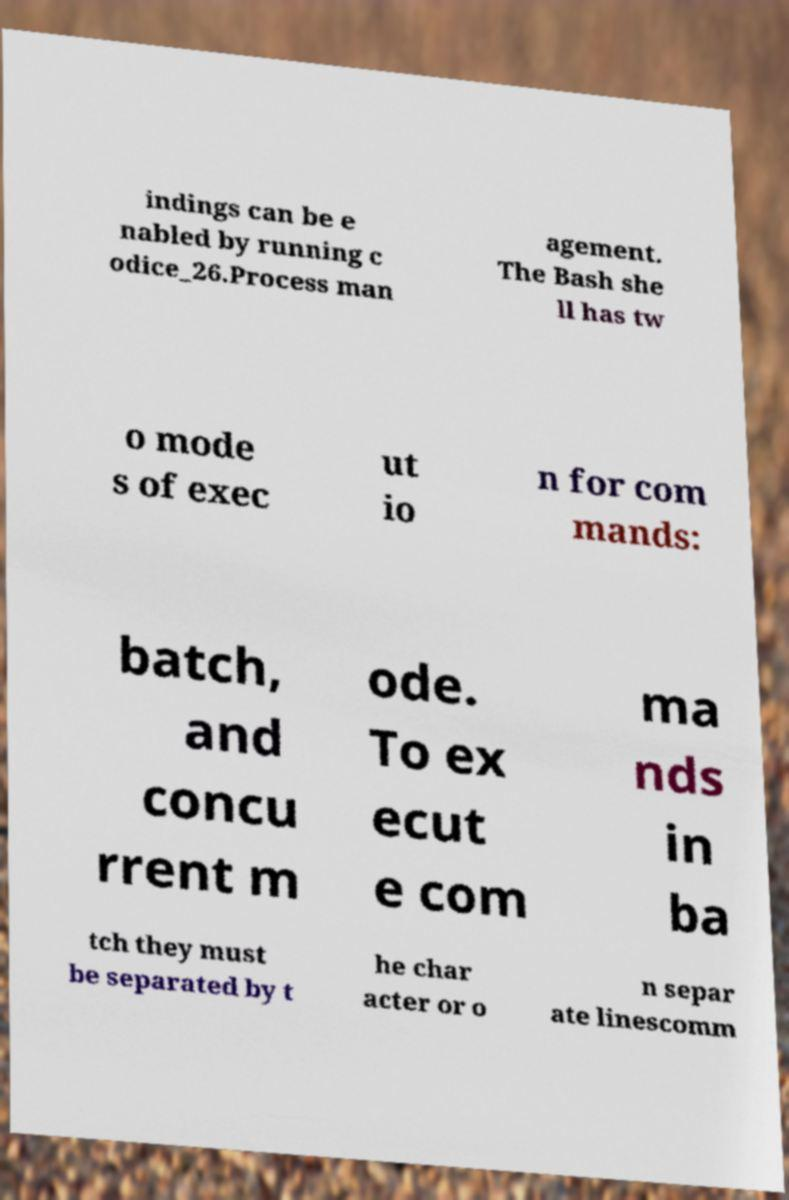There's text embedded in this image that I need extracted. Can you transcribe it verbatim? indings can be e nabled by running c odice_26.Process man agement. The Bash she ll has tw o mode s of exec ut io n for com mands: batch, and concu rrent m ode. To ex ecut e com ma nds in ba tch they must be separated by t he char acter or o n separ ate linescomm 